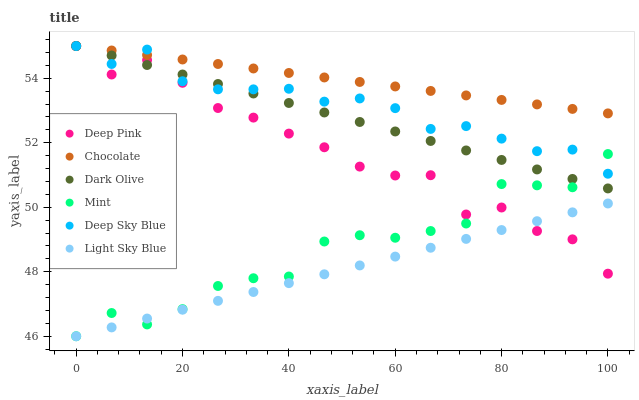Does Light Sky Blue have the minimum area under the curve?
Answer yes or no. Yes. Does Chocolate have the maximum area under the curve?
Answer yes or no. Yes. Does Dark Olive have the minimum area under the curve?
Answer yes or no. No. Does Dark Olive have the maximum area under the curve?
Answer yes or no. No. Is Light Sky Blue the smoothest?
Answer yes or no. Yes. Is Deep Pink the roughest?
Answer yes or no. Yes. Is Dark Olive the smoothest?
Answer yes or no. No. Is Dark Olive the roughest?
Answer yes or no. No. Does Light Sky Blue have the lowest value?
Answer yes or no. Yes. Does Dark Olive have the lowest value?
Answer yes or no. No. Does Deep Sky Blue have the highest value?
Answer yes or no. Yes. Does Light Sky Blue have the highest value?
Answer yes or no. No. Is Light Sky Blue less than Chocolate?
Answer yes or no. Yes. Is Deep Sky Blue greater than Light Sky Blue?
Answer yes or no. Yes. Does Deep Sky Blue intersect Deep Pink?
Answer yes or no. Yes. Is Deep Sky Blue less than Deep Pink?
Answer yes or no. No. Is Deep Sky Blue greater than Deep Pink?
Answer yes or no. No. Does Light Sky Blue intersect Chocolate?
Answer yes or no. No. 